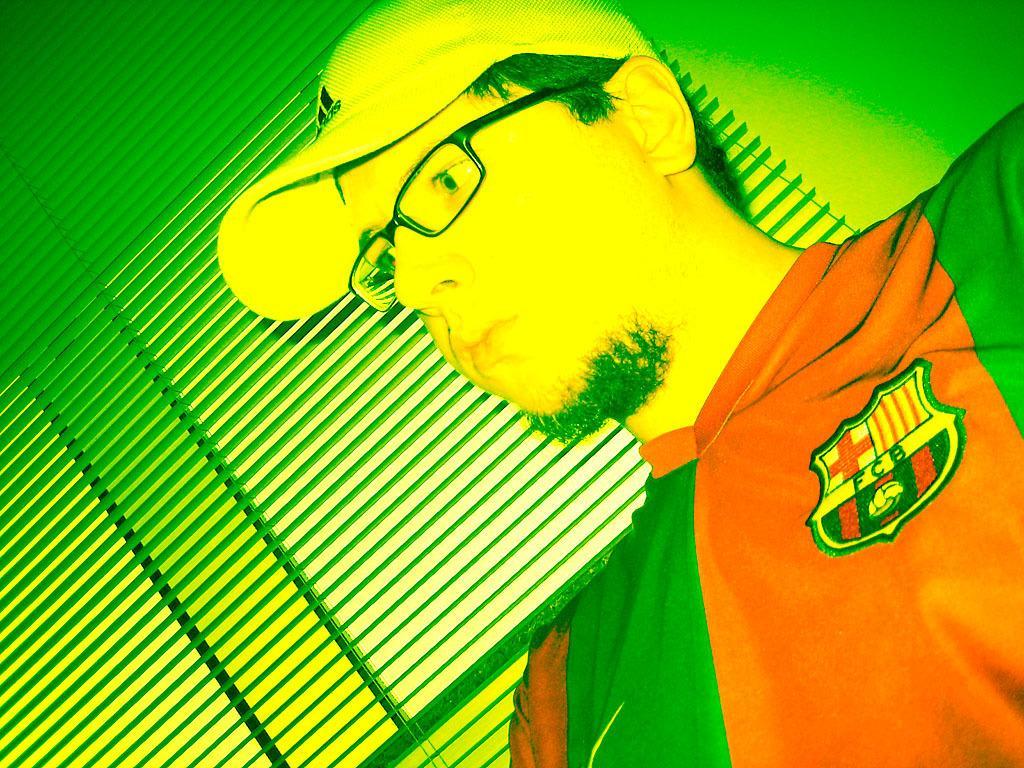Please provide a concise description of this image. This is an edited image. In this picture, we see a man is wearing the red and green T-shirt. He is wearing the spectacles and a cap. Behind him, we see a green wall and the window blind. In the background, it is green in color. 